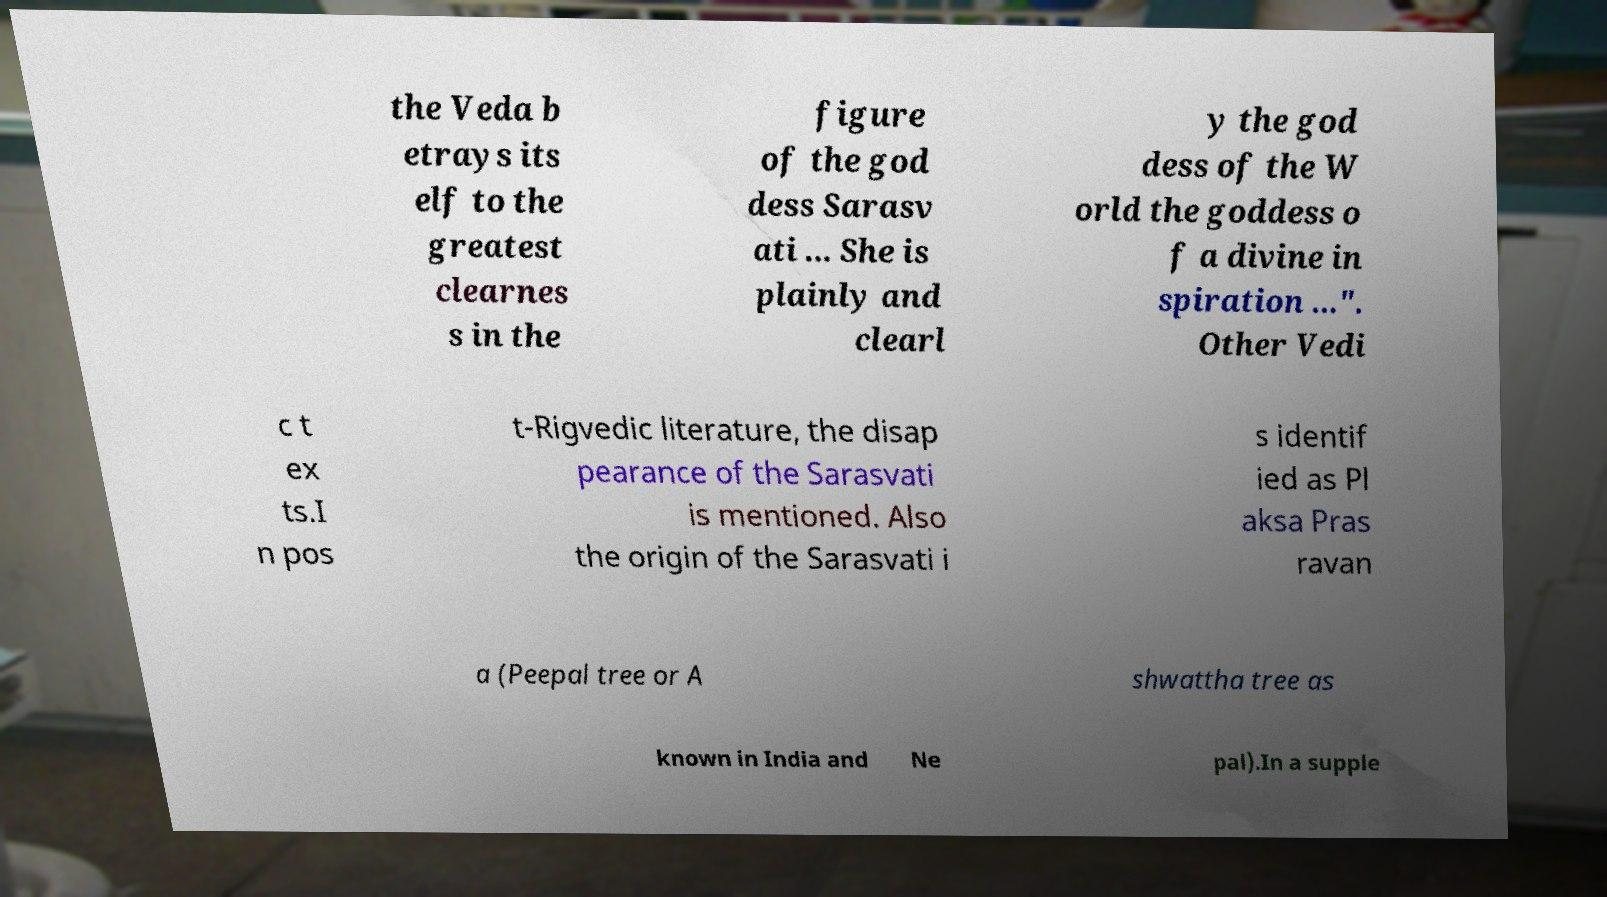I need the written content from this picture converted into text. Can you do that? the Veda b etrays its elf to the greatest clearnes s in the figure of the god dess Sarasv ati ... She is plainly and clearl y the god dess of the W orld the goddess o f a divine in spiration ...". Other Vedi c t ex ts.I n pos t-Rigvedic literature, the disap pearance of the Sarasvati is mentioned. Also the origin of the Sarasvati i s identif ied as Pl aksa Pras ravan a (Peepal tree or A shwattha tree as known in India and Ne pal).In a supple 